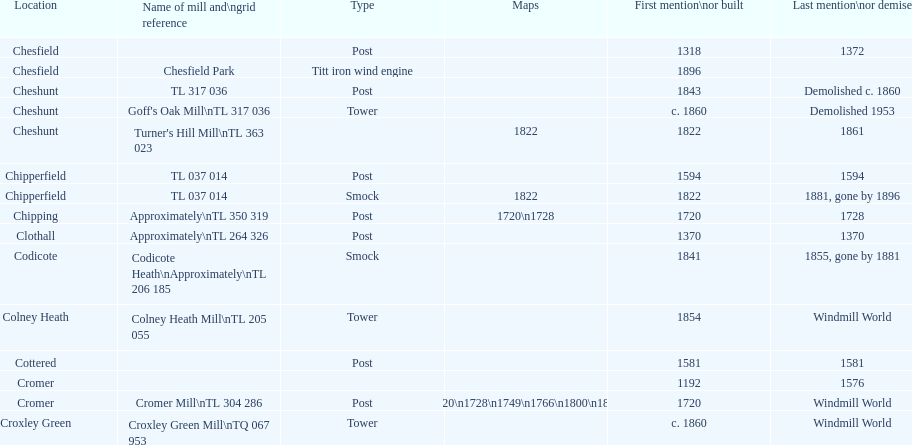What location has the most maps? Cromer. Parse the table in full. {'header': ['Location', 'Name of mill and\\ngrid reference', 'Type', 'Maps', 'First mention\\nor built', 'Last mention\\nor demise'], 'rows': [['Chesfield', '', 'Post', '', '1318', '1372'], ['Chesfield', 'Chesfield Park', 'Titt iron wind engine', '', '1896', ''], ['Cheshunt', 'TL 317 036', 'Post', '', '1843', 'Demolished c. 1860'], ['Cheshunt', "Goff's Oak Mill\\nTL 317 036", 'Tower', '', 'c. 1860', 'Demolished 1953'], ['Cheshunt', "Turner's Hill Mill\\nTL 363 023", '', '1822', '1822', '1861'], ['Chipperfield', 'TL 037 014', 'Post', '', '1594', '1594'], ['Chipperfield', 'TL 037 014', 'Smock', '1822', '1822', '1881, gone by 1896'], ['Chipping', 'Approximately\\nTL 350 319', 'Post', '1720\\n1728', '1720', '1728'], ['Clothall', 'Approximately\\nTL 264 326', 'Post', '', '1370', '1370'], ['Codicote', 'Codicote Heath\\nApproximately\\nTL 206 185', 'Smock', '', '1841', '1855, gone by 1881'], ['Colney Heath', 'Colney Heath Mill\\nTL 205 055', 'Tower', '', '1854', 'Windmill World'], ['Cottered', '', 'Post', '', '1581', '1581'], ['Cromer', '', '', '', '1192', '1576'], ['Cromer', 'Cromer Mill\\nTL 304 286', 'Post', '1720\\n1728\\n1749\\n1766\\n1800\\n1822', '1720', 'Windmill World'], ['Croxley Green', 'Croxley Green Mill\\nTQ 067 953', 'Tower', '', 'c. 1860', 'Windmill World']]} 